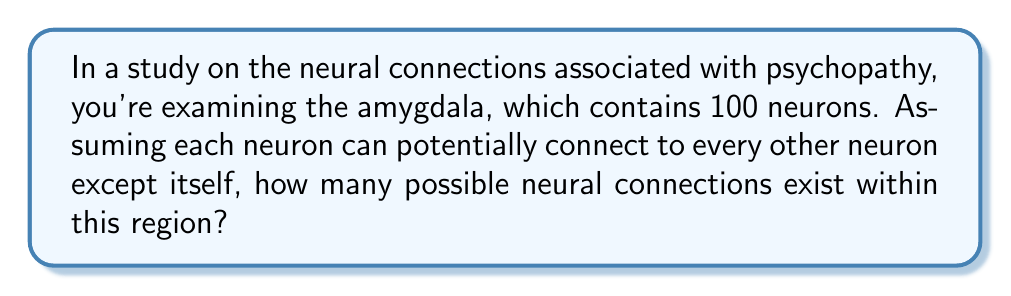Can you answer this question? Let's approach this step-by-step:

1) We have 100 neurons in total.

2) Each neuron can connect to every other neuron except itself. This means each neuron can connect to 99 other neurons.

3) If we were to count every possible connection from each neuron, we would get:
   $100 * 99 = 9900$

4) However, this count includes each connection twice. For example, the connection from neuron A to neuron B is counted separately from the connection from neuron B to neuron A, but these are the same connection.

5) To correct for this double-counting, we need to divide our total by 2:

   $$\text{Number of connections} = \frac{100 * 99}{2} = \frac{9900}{2} = 4950$$

6) We can generalize this formula. For n neurons, the number of possible connections is:

   $$\text{Number of connections} = \frac{n(n-1)}{2}$$

   This is also known as the combination formula $\binom{n}{2}$ or "n choose 2".
Answer: 4950 